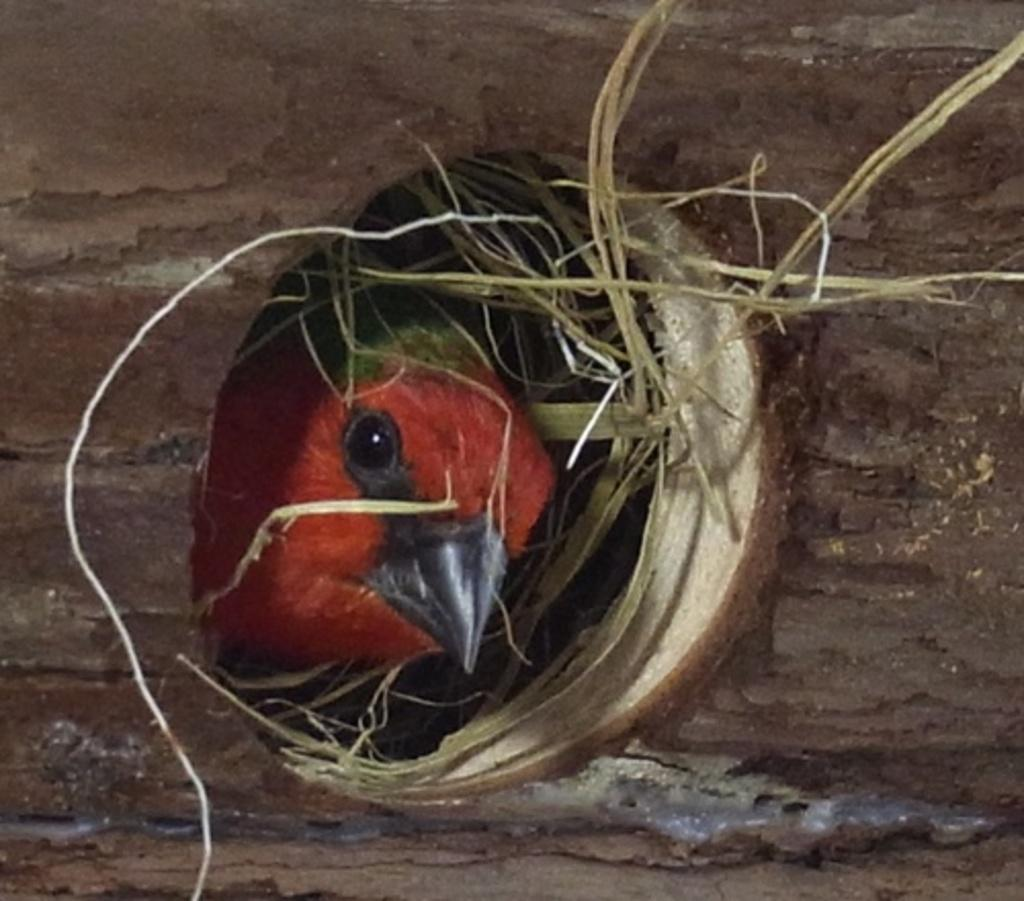What type of bird can be seen in the image? There is a red color bird in the image. Where is the bird located? The bird is in a nest. How many apples are balanced on the bird's head in the image? There are no apples present in the image, and the bird's head is not shown. 